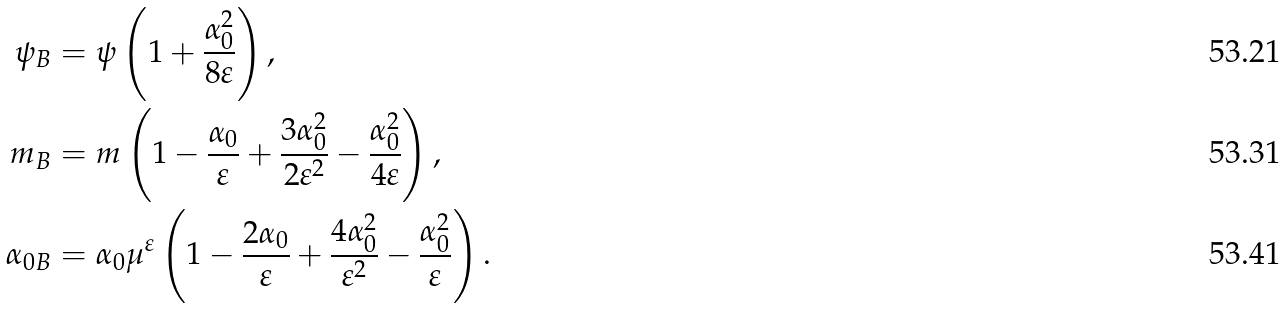Convert formula to latex. <formula><loc_0><loc_0><loc_500><loc_500>\psi _ { B } & = \psi \left ( 1 + \frac { \alpha _ { 0 } ^ { 2 } } { 8 \varepsilon } \right ) , \\ m _ { B } & = m \left ( 1 - \frac { \alpha _ { 0 } } { \varepsilon } + \frac { 3 \alpha _ { 0 } ^ { 2 } } { 2 \varepsilon ^ { 2 } } - \frac { \alpha _ { 0 } ^ { 2 } } { 4 \varepsilon } \right ) , \\ \alpha _ { 0 B } & = \alpha _ { 0 } \mu ^ { \varepsilon } \left ( 1 - \frac { 2 \alpha _ { 0 } } { \varepsilon } + \frac { 4 \alpha _ { 0 } ^ { 2 } } { \varepsilon ^ { 2 } } - \frac { \alpha _ { 0 } ^ { 2 } } { \varepsilon } \right ) .</formula> 